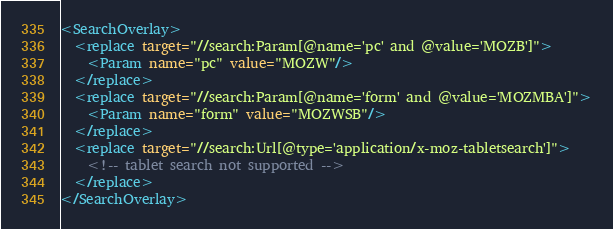Convert code to text. <code><loc_0><loc_0><loc_500><loc_500><_XML_><SearchOverlay>
  <replace target="//search:Param[@name='pc' and @value='MOZB']">
    <Param name="pc" value="MOZW"/>
  </replace>
  <replace target="//search:Param[@name='form' and @value='MOZMBA']">
    <Param name="form" value="MOZWSB"/>
  </replace>
  <replace target="//search:Url[@type='application/x-moz-tabletsearch']">
    <!-- tablet search not supported -->
  </replace>
</SearchOverlay>
</code> 